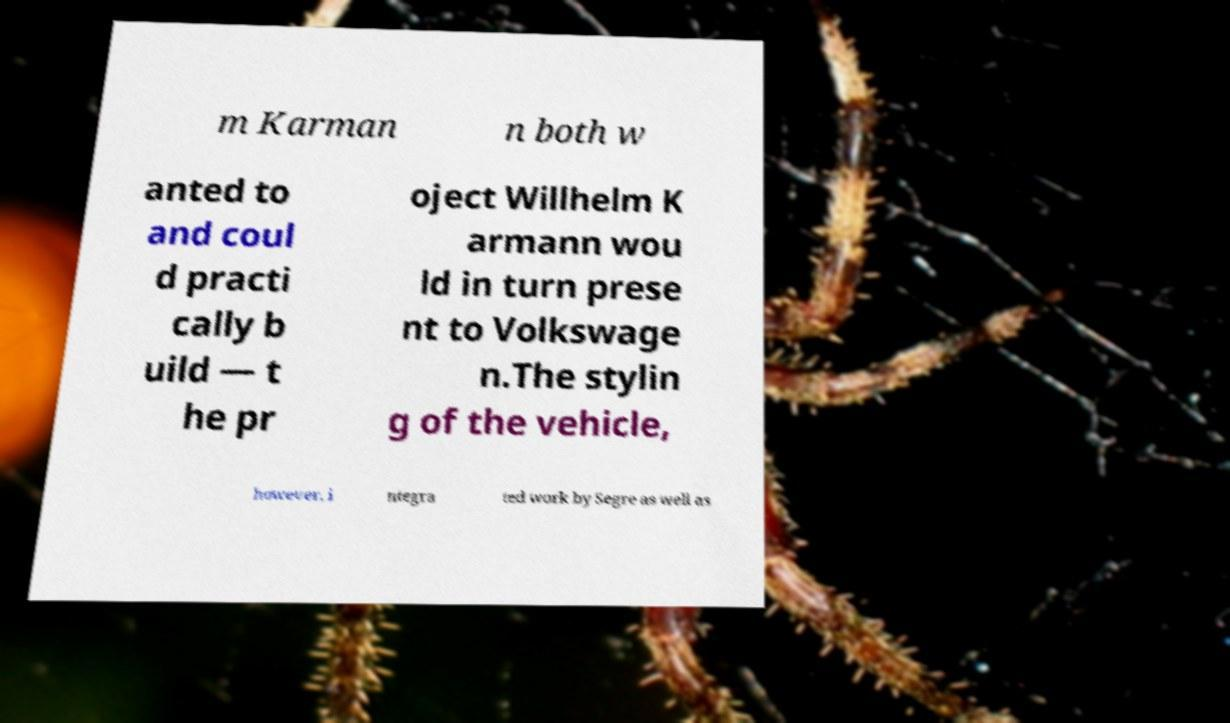I need the written content from this picture converted into text. Can you do that? m Karman n both w anted to and coul d practi cally b uild — t he pr oject Willhelm K armann wou ld in turn prese nt to Volkswage n.The stylin g of the vehicle, however, i ntegra ted work by Segre as well as 